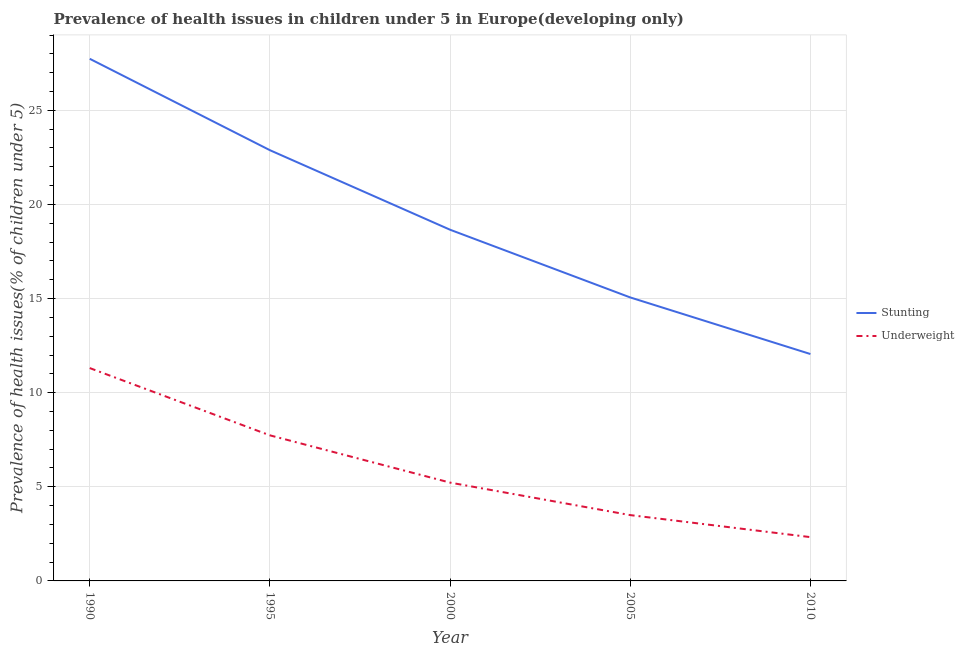Does the line corresponding to percentage of stunted children intersect with the line corresponding to percentage of underweight children?
Provide a short and direct response. No. What is the percentage of stunted children in 1995?
Your response must be concise. 22.88. Across all years, what is the maximum percentage of underweight children?
Your answer should be compact. 11.31. Across all years, what is the minimum percentage of stunted children?
Provide a short and direct response. 12.05. In which year was the percentage of stunted children minimum?
Make the answer very short. 2010. What is the total percentage of underweight children in the graph?
Offer a terse response. 30.09. What is the difference between the percentage of stunted children in 1990 and that in 2010?
Provide a succinct answer. 15.68. What is the difference between the percentage of underweight children in 2005 and the percentage of stunted children in 2000?
Give a very brief answer. -15.16. What is the average percentage of underweight children per year?
Offer a very short reply. 6.02. In the year 1995, what is the difference between the percentage of stunted children and percentage of underweight children?
Your answer should be very brief. 15.15. In how many years, is the percentage of stunted children greater than 5 %?
Provide a short and direct response. 5. What is the ratio of the percentage of underweight children in 1995 to that in 2000?
Ensure brevity in your answer.  1.48. Is the percentage of underweight children in 2000 less than that in 2005?
Offer a terse response. No. Is the difference between the percentage of stunted children in 1990 and 2005 greater than the difference between the percentage of underweight children in 1990 and 2005?
Provide a short and direct response. Yes. What is the difference between the highest and the second highest percentage of underweight children?
Provide a short and direct response. 3.57. What is the difference between the highest and the lowest percentage of underweight children?
Your answer should be very brief. 8.98. In how many years, is the percentage of stunted children greater than the average percentage of stunted children taken over all years?
Keep it short and to the point. 2. Is the percentage of underweight children strictly less than the percentage of stunted children over the years?
Provide a succinct answer. Yes. Where does the legend appear in the graph?
Give a very brief answer. Center right. What is the title of the graph?
Ensure brevity in your answer.  Prevalence of health issues in children under 5 in Europe(developing only). Does "Non-solid fuel" appear as one of the legend labels in the graph?
Your answer should be compact. No. What is the label or title of the Y-axis?
Make the answer very short. Prevalence of health issues(% of children under 5). What is the Prevalence of health issues(% of children under 5) of Stunting in 1990?
Provide a short and direct response. 27.74. What is the Prevalence of health issues(% of children under 5) in Underweight in 1990?
Provide a short and direct response. 11.31. What is the Prevalence of health issues(% of children under 5) in Stunting in 1995?
Ensure brevity in your answer.  22.88. What is the Prevalence of health issues(% of children under 5) of Underweight in 1995?
Provide a succinct answer. 7.73. What is the Prevalence of health issues(% of children under 5) in Stunting in 2000?
Offer a terse response. 18.66. What is the Prevalence of health issues(% of children under 5) in Underweight in 2000?
Give a very brief answer. 5.22. What is the Prevalence of health issues(% of children under 5) in Stunting in 2005?
Make the answer very short. 15.06. What is the Prevalence of health issues(% of children under 5) in Underweight in 2005?
Provide a succinct answer. 3.5. What is the Prevalence of health issues(% of children under 5) in Stunting in 2010?
Your answer should be compact. 12.05. What is the Prevalence of health issues(% of children under 5) in Underweight in 2010?
Your response must be concise. 2.33. Across all years, what is the maximum Prevalence of health issues(% of children under 5) in Stunting?
Provide a short and direct response. 27.74. Across all years, what is the maximum Prevalence of health issues(% of children under 5) of Underweight?
Offer a terse response. 11.31. Across all years, what is the minimum Prevalence of health issues(% of children under 5) of Stunting?
Your answer should be very brief. 12.05. Across all years, what is the minimum Prevalence of health issues(% of children under 5) of Underweight?
Offer a very short reply. 2.33. What is the total Prevalence of health issues(% of children under 5) of Stunting in the graph?
Provide a succinct answer. 96.39. What is the total Prevalence of health issues(% of children under 5) of Underweight in the graph?
Your answer should be very brief. 30.09. What is the difference between the Prevalence of health issues(% of children under 5) of Stunting in 1990 and that in 1995?
Provide a short and direct response. 4.86. What is the difference between the Prevalence of health issues(% of children under 5) of Underweight in 1990 and that in 1995?
Your answer should be very brief. 3.57. What is the difference between the Prevalence of health issues(% of children under 5) in Stunting in 1990 and that in 2000?
Provide a succinct answer. 9.08. What is the difference between the Prevalence of health issues(% of children under 5) of Underweight in 1990 and that in 2000?
Ensure brevity in your answer.  6.08. What is the difference between the Prevalence of health issues(% of children under 5) in Stunting in 1990 and that in 2005?
Offer a terse response. 12.68. What is the difference between the Prevalence of health issues(% of children under 5) in Underweight in 1990 and that in 2005?
Your response must be concise. 7.81. What is the difference between the Prevalence of health issues(% of children under 5) in Stunting in 1990 and that in 2010?
Offer a terse response. 15.68. What is the difference between the Prevalence of health issues(% of children under 5) in Underweight in 1990 and that in 2010?
Make the answer very short. 8.98. What is the difference between the Prevalence of health issues(% of children under 5) in Stunting in 1995 and that in 2000?
Your response must be concise. 4.22. What is the difference between the Prevalence of health issues(% of children under 5) in Underweight in 1995 and that in 2000?
Offer a very short reply. 2.51. What is the difference between the Prevalence of health issues(% of children under 5) in Stunting in 1995 and that in 2005?
Give a very brief answer. 7.82. What is the difference between the Prevalence of health issues(% of children under 5) of Underweight in 1995 and that in 2005?
Offer a terse response. 4.24. What is the difference between the Prevalence of health issues(% of children under 5) in Stunting in 1995 and that in 2010?
Provide a short and direct response. 10.83. What is the difference between the Prevalence of health issues(% of children under 5) in Underweight in 1995 and that in 2010?
Provide a short and direct response. 5.41. What is the difference between the Prevalence of health issues(% of children under 5) of Stunting in 2000 and that in 2005?
Make the answer very short. 3.6. What is the difference between the Prevalence of health issues(% of children under 5) of Underweight in 2000 and that in 2005?
Provide a short and direct response. 1.73. What is the difference between the Prevalence of health issues(% of children under 5) in Stunting in 2000 and that in 2010?
Your response must be concise. 6.6. What is the difference between the Prevalence of health issues(% of children under 5) in Underweight in 2000 and that in 2010?
Your answer should be very brief. 2.9. What is the difference between the Prevalence of health issues(% of children under 5) of Stunting in 2005 and that in 2010?
Provide a short and direct response. 3.01. What is the difference between the Prevalence of health issues(% of children under 5) in Underweight in 2005 and that in 2010?
Provide a short and direct response. 1.17. What is the difference between the Prevalence of health issues(% of children under 5) of Stunting in 1990 and the Prevalence of health issues(% of children under 5) of Underweight in 1995?
Provide a short and direct response. 20. What is the difference between the Prevalence of health issues(% of children under 5) of Stunting in 1990 and the Prevalence of health issues(% of children under 5) of Underweight in 2000?
Offer a very short reply. 22.51. What is the difference between the Prevalence of health issues(% of children under 5) of Stunting in 1990 and the Prevalence of health issues(% of children under 5) of Underweight in 2005?
Keep it short and to the point. 24.24. What is the difference between the Prevalence of health issues(% of children under 5) in Stunting in 1990 and the Prevalence of health issues(% of children under 5) in Underweight in 2010?
Provide a short and direct response. 25.41. What is the difference between the Prevalence of health issues(% of children under 5) of Stunting in 1995 and the Prevalence of health issues(% of children under 5) of Underweight in 2000?
Your answer should be very brief. 17.66. What is the difference between the Prevalence of health issues(% of children under 5) of Stunting in 1995 and the Prevalence of health issues(% of children under 5) of Underweight in 2005?
Your answer should be very brief. 19.39. What is the difference between the Prevalence of health issues(% of children under 5) of Stunting in 1995 and the Prevalence of health issues(% of children under 5) of Underweight in 2010?
Provide a succinct answer. 20.55. What is the difference between the Prevalence of health issues(% of children under 5) in Stunting in 2000 and the Prevalence of health issues(% of children under 5) in Underweight in 2005?
Ensure brevity in your answer.  15.16. What is the difference between the Prevalence of health issues(% of children under 5) in Stunting in 2000 and the Prevalence of health issues(% of children under 5) in Underweight in 2010?
Your response must be concise. 16.33. What is the difference between the Prevalence of health issues(% of children under 5) in Stunting in 2005 and the Prevalence of health issues(% of children under 5) in Underweight in 2010?
Your response must be concise. 12.73. What is the average Prevalence of health issues(% of children under 5) in Stunting per year?
Give a very brief answer. 19.28. What is the average Prevalence of health issues(% of children under 5) in Underweight per year?
Your answer should be very brief. 6.02. In the year 1990, what is the difference between the Prevalence of health issues(% of children under 5) in Stunting and Prevalence of health issues(% of children under 5) in Underweight?
Your response must be concise. 16.43. In the year 1995, what is the difference between the Prevalence of health issues(% of children under 5) of Stunting and Prevalence of health issues(% of children under 5) of Underweight?
Provide a succinct answer. 15.15. In the year 2000, what is the difference between the Prevalence of health issues(% of children under 5) of Stunting and Prevalence of health issues(% of children under 5) of Underweight?
Your answer should be compact. 13.43. In the year 2005, what is the difference between the Prevalence of health issues(% of children under 5) of Stunting and Prevalence of health issues(% of children under 5) of Underweight?
Provide a short and direct response. 11.56. In the year 2010, what is the difference between the Prevalence of health issues(% of children under 5) of Stunting and Prevalence of health issues(% of children under 5) of Underweight?
Keep it short and to the point. 9.73. What is the ratio of the Prevalence of health issues(% of children under 5) in Stunting in 1990 to that in 1995?
Offer a very short reply. 1.21. What is the ratio of the Prevalence of health issues(% of children under 5) in Underweight in 1990 to that in 1995?
Provide a succinct answer. 1.46. What is the ratio of the Prevalence of health issues(% of children under 5) of Stunting in 1990 to that in 2000?
Make the answer very short. 1.49. What is the ratio of the Prevalence of health issues(% of children under 5) in Underweight in 1990 to that in 2000?
Your response must be concise. 2.17. What is the ratio of the Prevalence of health issues(% of children under 5) of Stunting in 1990 to that in 2005?
Your response must be concise. 1.84. What is the ratio of the Prevalence of health issues(% of children under 5) of Underweight in 1990 to that in 2005?
Ensure brevity in your answer.  3.23. What is the ratio of the Prevalence of health issues(% of children under 5) in Stunting in 1990 to that in 2010?
Your response must be concise. 2.3. What is the ratio of the Prevalence of health issues(% of children under 5) in Underweight in 1990 to that in 2010?
Offer a very short reply. 4.86. What is the ratio of the Prevalence of health issues(% of children under 5) of Stunting in 1995 to that in 2000?
Keep it short and to the point. 1.23. What is the ratio of the Prevalence of health issues(% of children under 5) of Underweight in 1995 to that in 2000?
Your answer should be very brief. 1.48. What is the ratio of the Prevalence of health issues(% of children under 5) in Stunting in 1995 to that in 2005?
Your answer should be very brief. 1.52. What is the ratio of the Prevalence of health issues(% of children under 5) in Underweight in 1995 to that in 2005?
Your answer should be very brief. 2.21. What is the ratio of the Prevalence of health issues(% of children under 5) in Stunting in 1995 to that in 2010?
Your answer should be very brief. 1.9. What is the ratio of the Prevalence of health issues(% of children under 5) of Underweight in 1995 to that in 2010?
Make the answer very short. 3.32. What is the ratio of the Prevalence of health issues(% of children under 5) of Stunting in 2000 to that in 2005?
Make the answer very short. 1.24. What is the ratio of the Prevalence of health issues(% of children under 5) of Underweight in 2000 to that in 2005?
Provide a succinct answer. 1.49. What is the ratio of the Prevalence of health issues(% of children under 5) of Stunting in 2000 to that in 2010?
Offer a terse response. 1.55. What is the ratio of the Prevalence of health issues(% of children under 5) in Underweight in 2000 to that in 2010?
Your response must be concise. 2.24. What is the ratio of the Prevalence of health issues(% of children under 5) of Stunting in 2005 to that in 2010?
Offer a terse response. 1.25. What is the ratio of the Prevalence of health issues(% of children under 5) in Underweight in 2005 to that in 2010?
Provide a succinct answer. 1.5. What is the difference between the highest and the second highest Prevalence of health issues(% of children under 5) in Stunting?
Provide a succinct answer. 4.86. What is the difference between the highest and the second highest Prevalence of health issues(% of children under 5) of Underweight?
Keep it short and to the point. 3.57. What is the difference between the highest and the lowest Prevalence of health issues(% of children under 5) in Stunting?
Ensure brevity in your answer.  15.68. What is the difference between the highest and the lowest Prevalence of health issues(% of children under 5) in Underweight?
Ensure brevity in your answer.  8.98. 